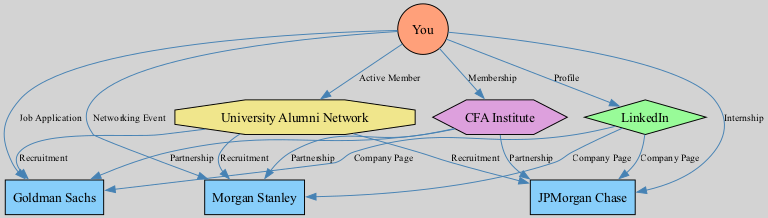What is the total number of nodes in the diagram? The diagram includes 7 nodes representing different entities, such as yourself, companies, a platform, an organization, and a network. Adding them gives us a total of 7 nodes.
Answer: 7 Which company is linked to your job application? The edge labeled "Job Application" connects you to Goldman Sachs, indicating that you have applied for a position there.
Answer: Goldman Sachs How many companies have a partnership with the CFA Institute? There are three edges connecting the CFA Institute to Goldman Sachs, JPMorgan Chase, and Morgan Stanley, indicating that all three companies have a partnership with the CFA Institute.
Answer: 3 Which platform do you use to maintain your professional profile? You are connected to LinkedIn through the edge labeled "Profile," indicating it is the platform where you maintain your professional presence.
Answer: LinkedIn What type of node represents the "University Alumni Network"? The node labeled "University Alumni Network" is categorized as a network type, as indicated by its octagonal shape in the diagram.
Answer: network Which companies are involved in recruitment through the University Alumni Network? The edges labeled "Recruitment" from the University Alumni Network indicate that Goldman Sachs, JPMorgan Chase, and Morgan Stanley are all involved in recruitment through this network.
Answer: Goldman Sachs, JPMorgan Chase, Morgan Stanley What relationship connects you to Morgan Stanley? The relationship labeled "Networking Event" signifies your connection to Morgan Stanley, indicating that this interaction occurred through attending an event.
Answer: Networking Event Which organization is represented in the diagram? The CFA Institute represents the organization in the diagram, indicated by its hexagonal shape and its connections to the companies.
Answer: CFA Institute How many edges originate from you to companies in the diagram? You have three edges that connect you to companies: one for job application, one for internship, and one for networking event, totaling three edges.
Answer: 3 